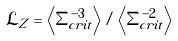Convert formula to latex. <formula><loc_0><loc_0><loc_500><loc_500>\mathcal { L } _ { Z } = \left < \Sigma _ { c r i t } ^ { - 3 } \right > / \left < \Sigma _ { c r i t } ^ { - 2 } \right ></formula> 